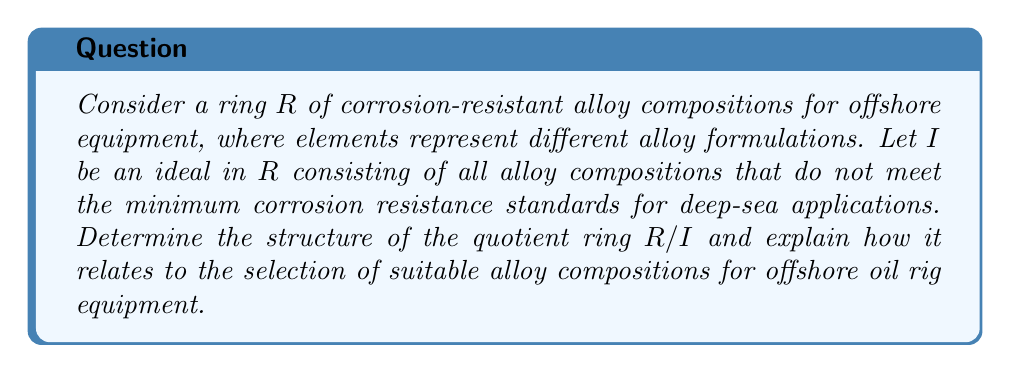Can you solve this math problem? To analyze the quotient ring $R/I$, we need to follow these steps:

1) First, let's understand what the ring $R$ represents:
   - Elements of $R$ are different alloy compositions
   - Addition in $R$ might represent combining alloys
   - Multiplication in $R$ could represent layering or treating alloys

2) The ideal $I$ consists of all alloy compositions that don't meet deep-sea standards. This means:
   $$I = \{x \in R : x \text{ does not meet minimum corrosion resistance}\}$$

3) The quotient ring $R/I$ is formed by the equivalence classes of elements in $R$ modulo $I$. In this context:
   - Two alloy compositions $a$ and $b$ are in the same equivalence class if $a - b \in I$
   - This means $a$ and $b$ differ only by an alloy composition that doesn't meet standards

4) The structure of $R/I$:
   - Each element in $R/I$ represents a class of alloy compositions that are equivalent in terms of meeting the corrosion resistance standards
   - The zero element in $R/I$ corresponds to the class of all alloy compositions that don't meet the standards (i.e., the ideal $I$ itself)
   - Non-zero elements in $R/I$ correspond to classes of alloy compositions that do meet the standards

5) Relation to alloy selection for offshore equipment:
   - The quotient ring $R/I$ effectively "filters out" all unsuitable alloy compositions
   - Each non-zero element in $R/I$ represents a class of suitable alloy compositions
   - Operations in $R/I$ (addition and multiplication) represent ways of combining or modifying suitable alloys while maintaining their suitability for deep-sea applications

6) The structure of $R/I$ provides a mathematical framework for:
   - Classifying suitable alloy compositions
   - Understanding how different suitable alloys relate to each other
   - Exploring combinations of suitable alloys that maintain necessary corrosion resistance
Answer: The quotient ring $R/I$ has a structure where each non-zero element represents an equivalence class of alloy compositions suitable for deep-sea applications. This ring provides a mathematical framework for classifying, relating, and combining corrosion-resistant alloys while ensuring they meet the minimum standards for offshore oil rig equipment. 